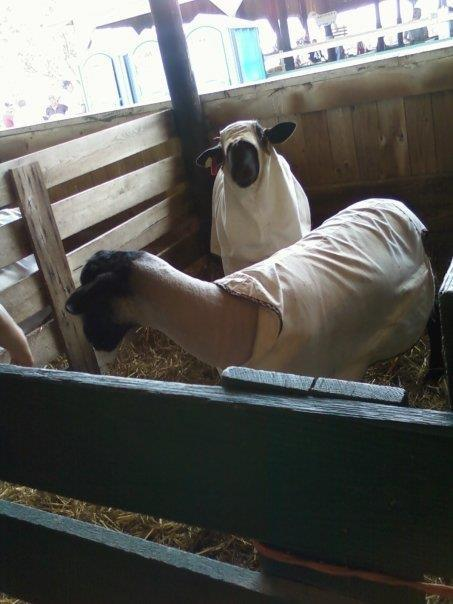What are the animals near? Please explain your reasoning. fence. The animals are by a fence. 